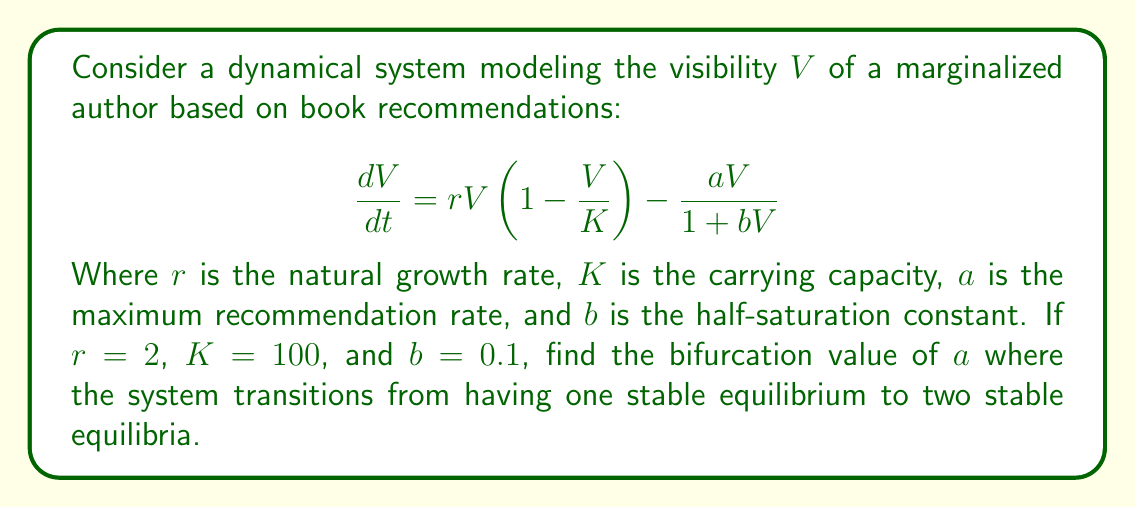Solve this math problem. To find the bifurcation value, we need to follow these steps:

1) First, find the equilibrium points by setting $\frac{dV}{dt} = 0$:

   $$0 = rV(1-\frac{V}{K}) - \frac{aV}{1+bV}$$

2) Simplify:

   $$0 = 2V(1-\frac{V}{100}) - \frac{aV}{1+0.1V}$$

3) Multiply both sides by $(1+0.1V)$:

   $$0 = 2V(1-\frac{V}{100})(1+0.1V) - aV$$

4) Expand:

   $$0 = 2V + 0.2V^2 - \frac{2V^2}{100} - \frac{0.2V^3}{100} - aV$$

5) Rearrange:

   $$0 = -0.002V^3 + 0.18V^2 + (2-a)V$$

6) At the bifurcation point, this cubic equation should have a double root. This occurs when the discriminant of the quadratic part (after factoring out V) is zero:

   $$\text{Discriminant} = (0.18)^2 - 4(-0.002)(2-a) = 0$$

7) Solve this equation:

   $$0.0324 - 0.008(2-a) = 0$$
   $$0.0324 - 0.016 + 0.008a = 0$$
   $$0.008a = -0.0164$$
   $$a = -2.05$$

8) Since $a$ represents a rate, it should be positive. The positive solution is:

   $$a = 2.05$$

This is the bifurcation value where the system transitions from one stable equilibrium to two stable equilibria.
Answer: $a = 2.05$ 